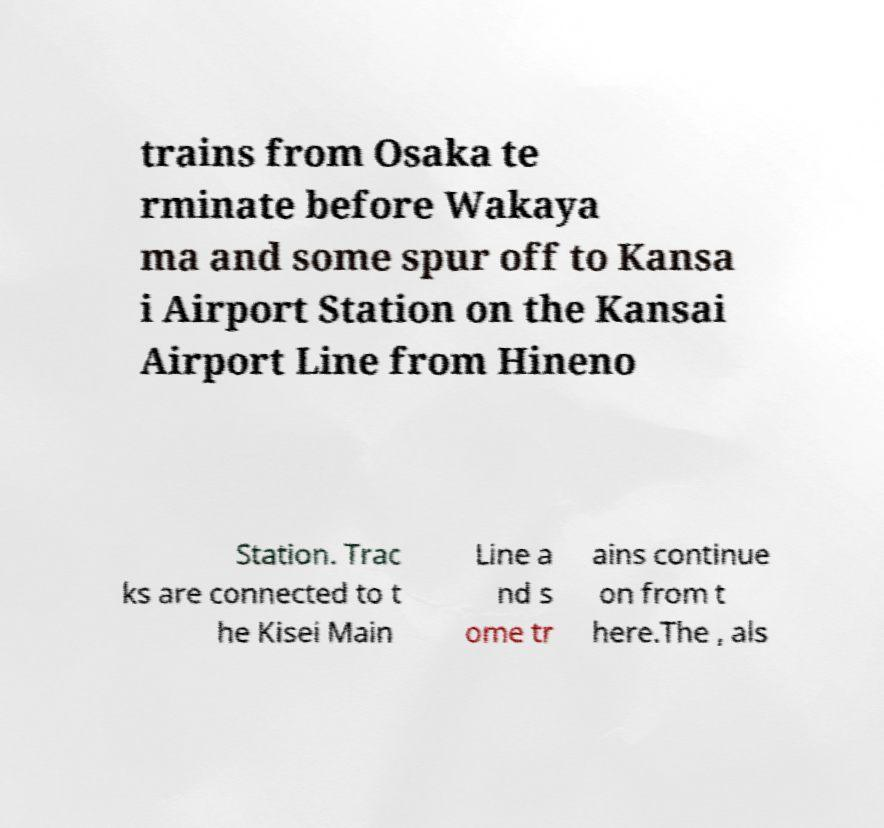I need the written content from this picture converted into text. Can you do that? trains from Osaka te rminate before Wakaya ma and some spur off to Kansa i Airport Station on the Kansai Airport Line from Hineno Station. Trac ks are connected to t he Kisei Main Line a nd s ome tr ains continue on from t here.The , als 